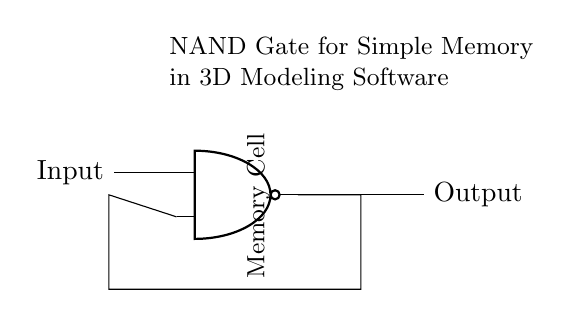What does the output of the NAND gate indicate? The output of the NAND gate indicates the inverse of the AND operation of its inputs; if both inputs are high, the output is low, otherwise it is high.
Answer: Memory Cell What are the inputs to the NAND gate? The inputs to the NAND gate are labeled in the circuit, and there are two input connections shown.
Answer: Input How many connections are there from the NAND gate? The NAND gate has one output connection going out and two input connections coming in, which makes a total of three connections.
Answer: Three Why would you use a NAND gate for memory cells? NAND gates are preferred for memory cells because they can store binary states and are used in various configurations to create stable memory structures.
Answer: Stability What does the label "Memory Cell" signify? The label "Memory Cell" signifies the function of this part of the circuit; it indicates that this section uses the NAND gate to store a binary state (0 or 1).
Answer: Functionality What is the orientation of the "Memory Cell" label? The label "Memory Cell" is rotated 90 degrees, making it a vertical orientation in relation to the NAND gate.
Answer: Vertical 